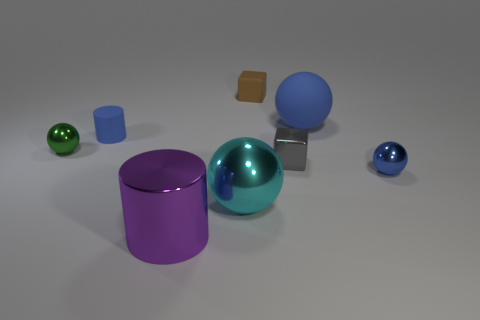There is a metal thing to the left of the small blue matte object; are there any green balls behind it?
Your response must be concise. No. What number of other objects are there of the same shape as the big purple object?
Make the answer very short. 1. There is a small blue thing that is right of the purple metallic thing; does it have the same shape as the object on the left side of the blue cylinder?
Offer a terse response. Yes. What number of rubber cubes are to the right of the small shiny ball to the right of the cube that is left of the gray thing?
Offer a very short reply. 0. The small cylinder is what color?
Give a very brief answer. Blue. How many other things are there of the same size as the blue rubber cylinder?
Provide a succinct answer. 4. What is the material of the brown object that is the same shape as the gray thing?
Ensure brevity in your answer.  Rubber. There is a tiny block behind the large thing that is right of the big metal thing that is behind the big shiny cylinder; what is its material?
Make the answer very short. Rubber. What size is the green sphere that is made of the same material as the purple thing?
Your answer should be very brief. Small. Is there any other thing that is the same color as the small matte block?
Offer a terse response. No. 